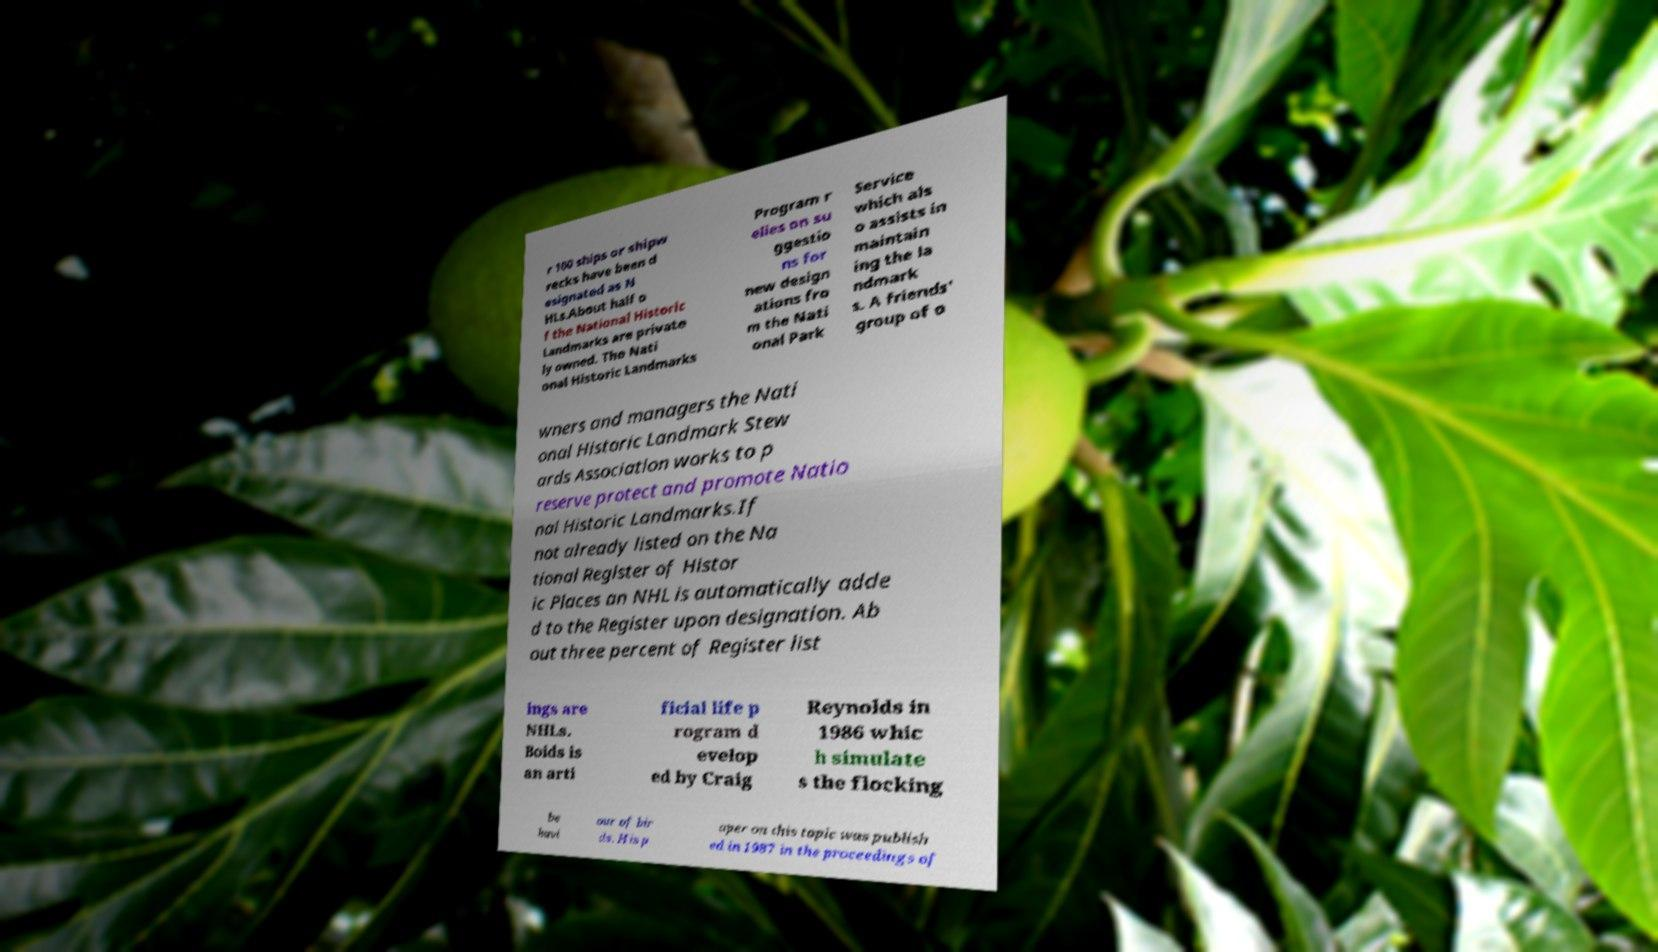Please read and relay the text visible in this image. What does it say? r 100 ships or shipw recks have been d esignated as N HLs.About half o f the National Historic Landmarks are private ly owned. The Nati onal Historic Landmarks Program r elies on su ggestio ns for new design ations fro m the Nati onal Park Service which als o assists in maintain ing the la ndmark s. A friends' group of o wners and managers the Nati onal Historic Landmark Stew ards Association works to p reserve protect and promote Natio nal Historic Landmarks.If not already listed on the Na tional Register of Histor ic Places an NHL is automatically adde d to the Register upon designation. Ab out three percent of Register list ings are NHLs. Boids is an arti ficial life p rogram d evelop ed by Craig Reynolds in 1986 whic h simulate s the flocking be havi our of bir ds. His p aper on this topic was publish ed in 1987 in the proceedings of 